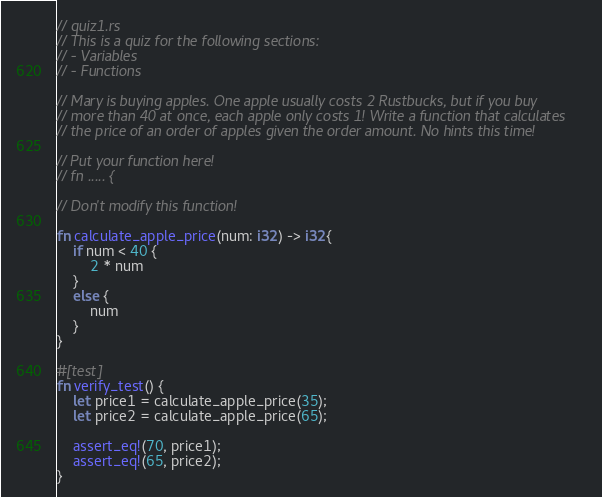<code> <loc_0><loc_0><loc_500><loc_500><_Rust_>// quiz1.rs
// This is a quiz for the following sections:
// - Variables
// - Functions

// Mary is buying apples. One apple usually costs 2 Rustbucks, but if you buy
// more than 40 at once, each apple only costs 1! Write a function that calculates
// the price of an order of apples given the order amount. No hints this time!

// Put your function here!
// fn ..... {

// Don't modify this function!

fn calculate_apple_price(num: i32) -> i32{
    if num < 40 {
        2 * num
    }
    else {
        num
    }
}

#[test]
fn verify_test() {
    let price1 = calculate_apple_price(35);
    let price2 = calculate_apple_price(65);

    assert_eq!(70, price1);
    assert_eq!(65, price2);
}
</code> 